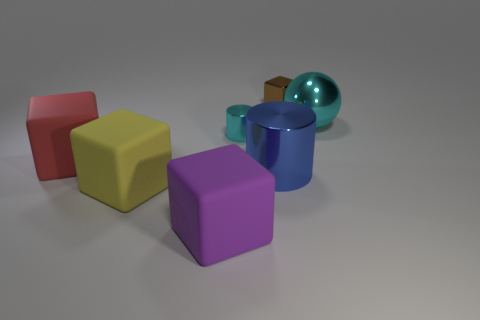Is there anything else that has the same shape as the brown thing?
Give a very brief answer. Yes. What is the color of the tiny cylinder?
Offer a very short reply. Cyan. How many blue things have the same shape as the big purple rubber thing?
Provide a succinct answer. 0. What is the color of the metallic cylinder that is the same size as the red rubber thing?
Ensure brevity in your answer.  Blue. Are there any large shiny cylinders?
Offer a very short reply. Yes. What shape is the big object right of the brown cube?
Your answer should be compact. Sphere. What number of things are to the right of the big purple matte block and to the left of the large blue shiny thing?
Your answer should be compact. 1. Is there a big blue object that has the same material as the brown block?
Give a very brief answer. Yes. The shiny cylinder that is the same color as the ball is what size?
Your response must be concise. Small. What number of spheres are either blue things or large yellow metal objects?
Ensure brevity in your answer.  0. 